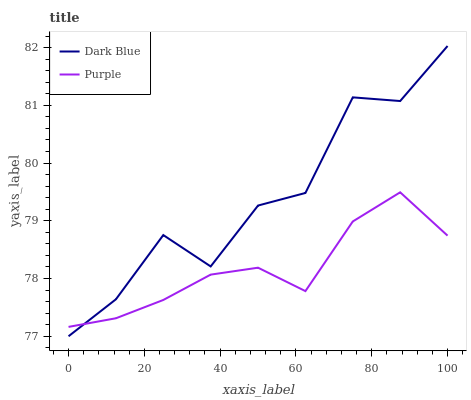Does Dark Blue have the minimum area under the curve?
Answer yes or no. No. Is Dark Blue the smoothest?
Answer yes or no. No. 